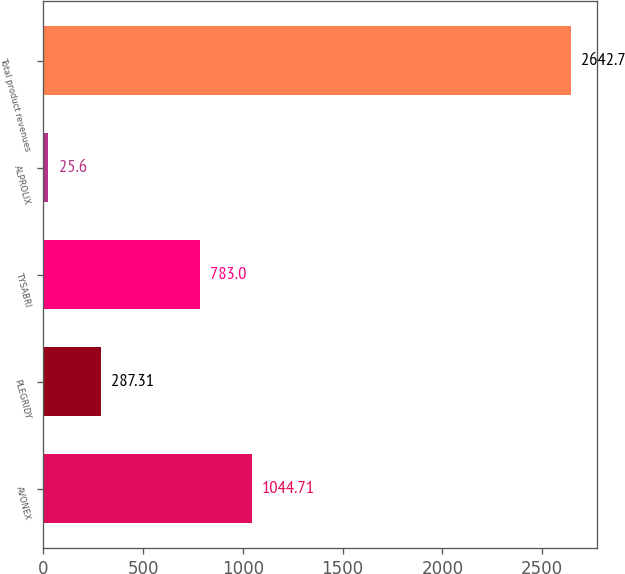Convert chart. <chart><loc_0><loc_0><loc_500><loc_500><bar_chart><fcel>AVONEX<fcel>PLEGRIDY<fcel>TYSABRI<fcel>ALPROLIX<fcel>Total product revenues<nl><fcel>1044.71<fcel>287.31<fcel>783<fcel>25.6<fcel>2642.7<nl></chart> 